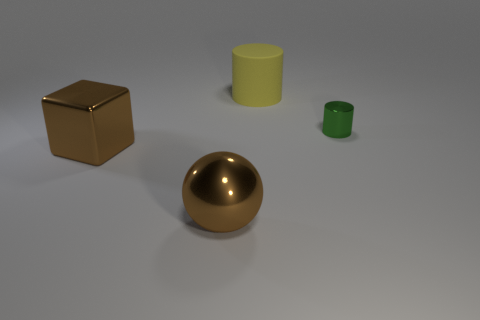There is a block that is the same color as the large sphere; what is its material?
Make the answer very short. Metal. There is a yellow matte thing; is its size the same as the object that is right of the large matte cylinder?
Your response must be concise. No. Is there any other thing that has the same shape as the green object?
Your answer should be compact. Yes. How many big metal objects are there?
Your answer should be compact. 2. How many green things are either large blocks or shiny balls?
Offer a very short reply. 0. Are the object that is to the right of the big yellow thing and the yellow thing made of the same material?
Your answer should be very brief. No. How many other things are the same material as the brown block?
Provide a short and direct response. 2. What is the material of the tiny green object?
Provide a short and direct response. Metal. What is the size of the brown object that is on the left side of the big ball?
Your answer should be compact. Large. What number of large things are in front of the cylinder that is to the left of the small green metal object?
Your answer should be compact. 2. 